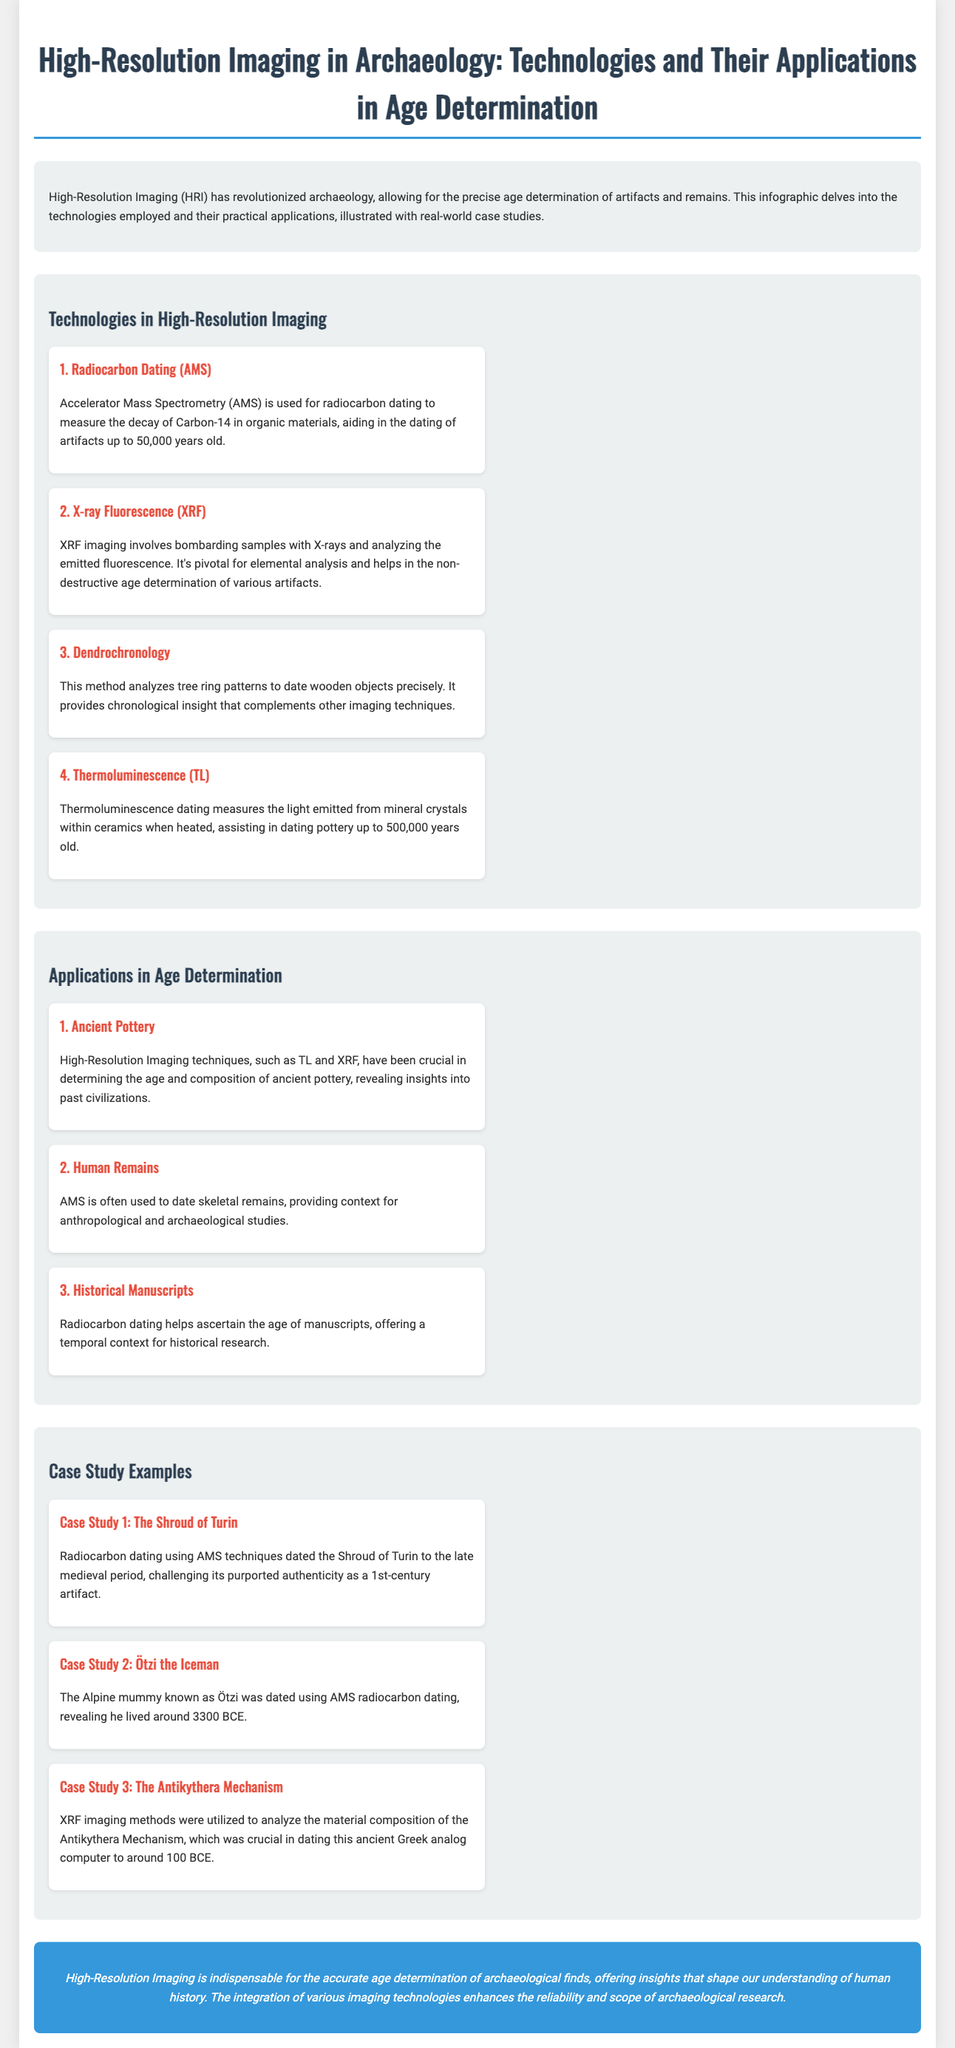What is the title of the infographic? The title is a key piece of information presented prominently at the top of the document.
Answer: High-Resolution Imaging in Archaeology: Technologies and Their Applications in Age Determination What technology is used for dating artifacts up to 50,000 years old? This technology is specifically mentioned in the section detailing the technologies used in High-Resolution Imaging.
Answer: Radiocarbon Dating (AMS) What does XRF stand for? XRF is an abbreviation that stands for a specific imaging technique mentioned in the document.
Answer: X-ray Fluorescence Which case study reveals the age of the Alpine mummy? This question requires identifying specific details about age determination in a case study mentioned in the document.
Answer: Ötzi the Iceman How old can Thermoluminescence date ceramics? This question addresses the specific time range provided for a technology's application in the document.
Answer: 500,000 years old Which technique helps ascertain the age of historical manuscripts? This technique is highlighted as a method for determining the age of certain artifacts, as described in the applications section.
Answer: Radiocarbon dating What was the purpose of high-resolution imaging in determining the age of ancient pottery? This question asks for the significance of imaging techniques in a specific application mentioned in the document.
Answer: Age and composition What is mentioned as a conclusion about High-Resolution Imaging's contribution? The conclusion summarizes the key findings and insights presented throughout the document.
Answer: Indispensable for accurate age determination How many case studies are presented in the infographic? This question wants to know the quantity of specific examples provided to illustrate High-Resolution Imaging applications.
Answer: Three 